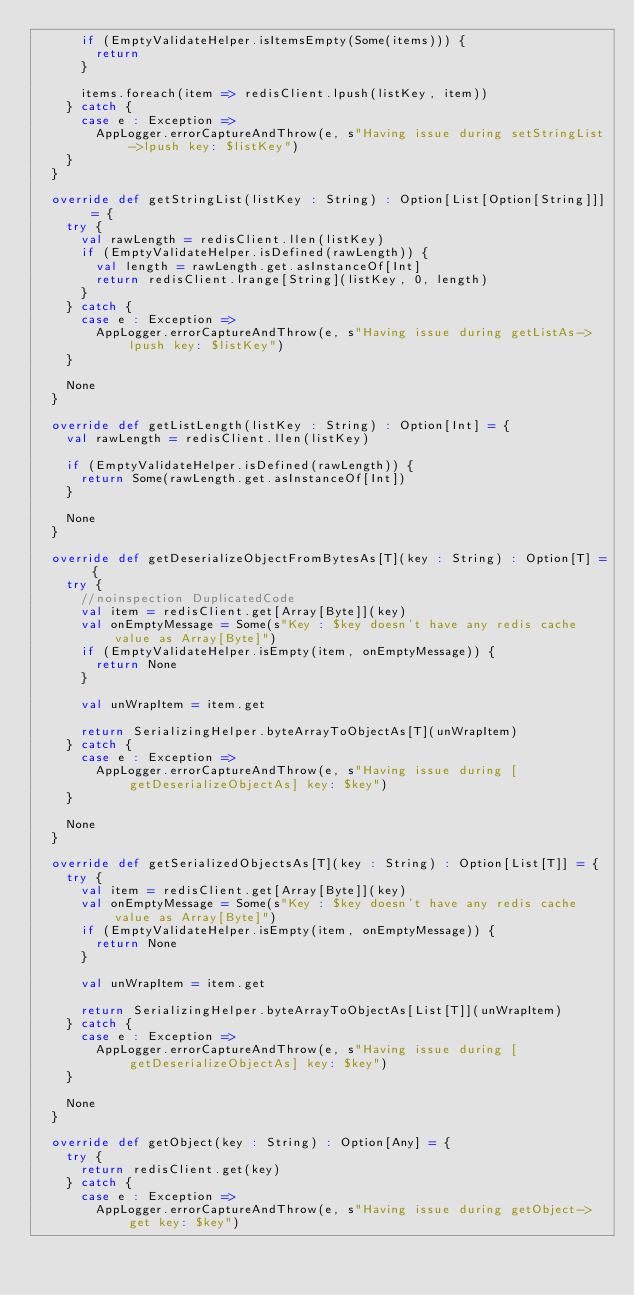Convert code to text. <code><loc_0><loc_0><loc_500><loc_500><_Scala_>      if (EmptyValidateHelper.isItemsEmpty(Some(items))) {
        return
      }

      items.foreach(item => redisClient.lpush(listKey, item))
    } catch {
      case e : Exception =>
        AppLogger.errorCaptureAndThrow(e, s"Having issue during setStringList->lpush key: $listKey")
    }
  }

  override def getStringList(listKey : String) : Option[List[Option[String]]] = {
    try {
      val rawLength = redisClient.llen(listKey)
      if (EmptyValidateHelper.isDefined(rawLength)) {
        val length = rawLength.get.asInstanceOf[Int]
        return redisClient.lrange[String](listKey, 0, length)
      }
    } catch {
      case e : Exception =>
        AppLogger.errorCaptureAndThrow(e, s"Having issue during getListAs->lpush key: $listKey")
    }

    None
  }

  override def getListLength(listKey : String) : Option[Int] = {
    val rawLength = redisClient.llen(listKey)

    if (EmptyValidateHelper.isDefined(rawLength)) {
      return Some(rawLength.get.asInstanceOf[Int])
    }

    None
  }

  override def getDeserializeObjectFromBytesAs[T](key : String) : Option[T] = {
    try {
      //noinspection DuplicatedCode
      val item = redisClient.get[Array[Byte]](key)
      val onEmptyMessage = Some(s"Key : $key doesn't have any redis cache value as Array[Byte]")
      if (EmptyValidateHelper.isEmpty(item, onEmptyMessage)) {
        return None
      }

      val unWrapItem = item.get

      return SerializingHelper.byteArrayToObjectAs[T](unWrapItem)
    } catch {
      case e : Exception =>
        AppLogger.errorCaptureAndThrow(e, s"Having issue during [getDeserializeObjectAs] key: $key")
    }

    None
  }

  override def getSerializedObjectsAs[T](key : String) : Option[List[T]] = {
    try {
      val item = redisClient.get[Array[Byte]](key)
      val onEmptyMessage = Some(s"Key : $key doesn't have any redis cache value as Array[Byte]")
      if (EmptyValidateHelper.isEmpty(item, onEmptyMessage)) {
        return None
      }

      val unWrapItem = item.get

      return SerializingHelper.byteArrayToObjectAs[List[T]](unWrapItem)
    } catch {
      case e : Exception =>
        AppLogger.errorCaptureAndThrow(e, s"Having issue during [getDeserializeObjectAs] key: $key")
    }

    None
  }

  override def getObject(key : String) : Option[Any] = {
    try {
      return redisClient.get(key)
    } catch {
      case e : Exception =>
        AppLogger.errorCaptureAndThrow(e, s"Having issue during getObject->get key: $key")</code> 